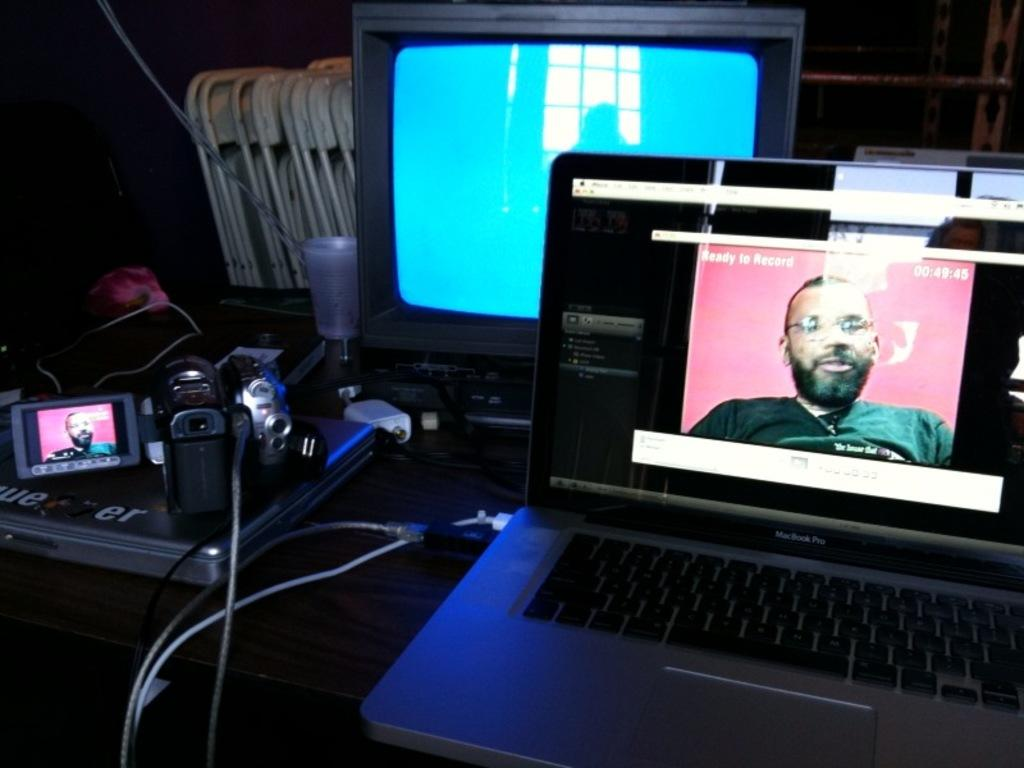<image>
Write a terse but informative summary of the picture. A screen on a laptop says "ready to record" over a pink background. 